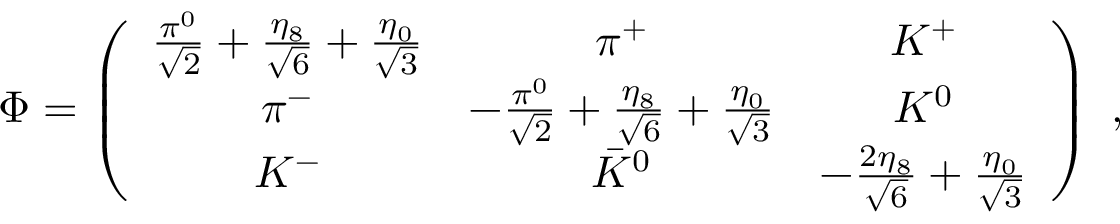<formula> <loc_0><loc_0><loc_500><loc_500>\Phi = \left ( \begin{array} { c c c } { { { \frac { \pi ^ { 0 } } { \sqrt { 2 } } } + { \frac { \eta _ { 8 } } { \sqrt { 6 } } } + { \frac { \eta _ { 0 } } { \sqrt { 3 } } } } } & { { \pi ^ { + } } } & { { K ^ { + } } } \\ { { \pi ^ { - } } } & { { - { \frac { \pi ^ { 0 } } { \sqrt { 2 } } } + { \frac { \eta _ { 8 } } { \sqrt { 6 } } } + { \frac { \eta _ { 0 } } { \sqrt { 3 } } } } } & { { K ^ { 0 } } } \\ { { K ^ { - } } } & { { \bar { K } ^ { 0 } } } & { { - { \frac { 2 \eta _ { 8 } } { \sqrt { 6 } } } + { \frac { \eta _ { 0 } } { \sqrt { 3 } } } } } \end{array} \right ) \ ,</formula> 